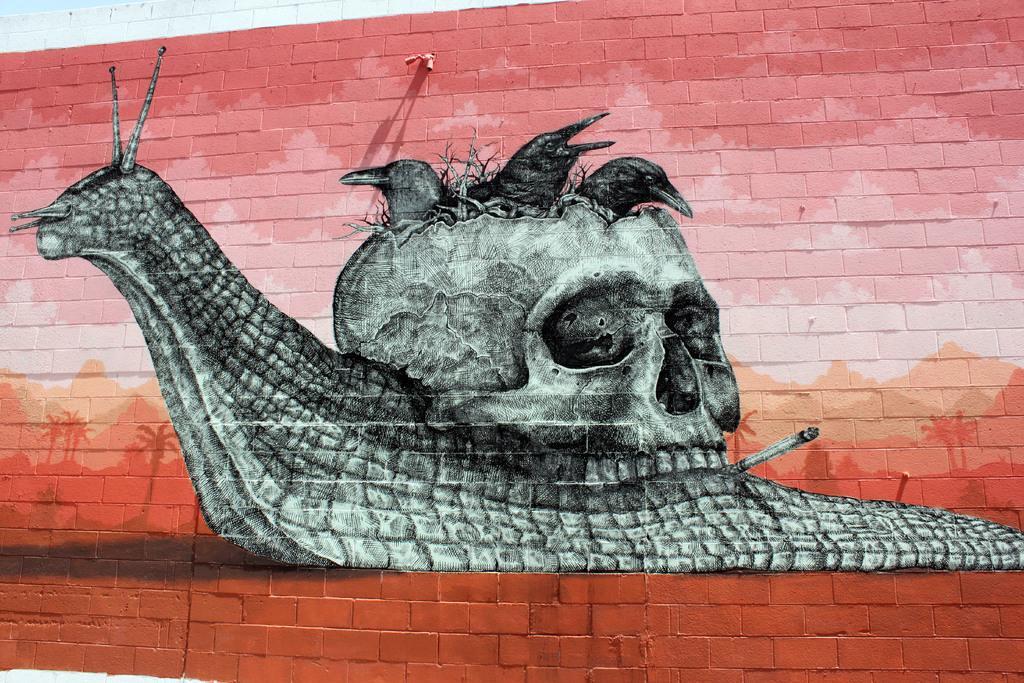In one or two sentences, can you explain what this image depicts? In this image I can see a wall which is made of bricks which is white and red in color and on the wall I can see the painting of a snail which is white and black in color and I can see a skull and few birds in the skull. 